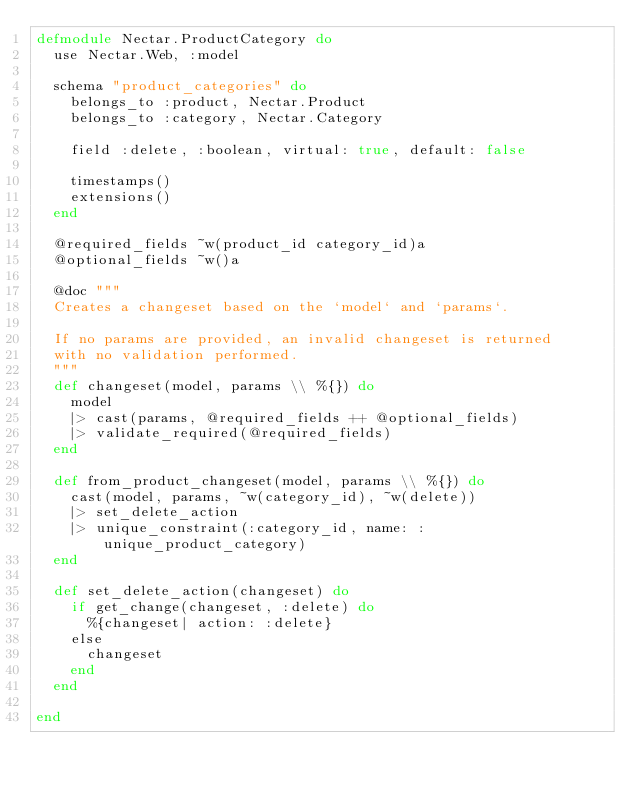Convert code to text. <code><loc_0><loc_0><loc_500><loc_500><_Elixir_>defmodule Nectar.ProductCategory do
  use Nectar.Web, :model

  schema "product_categories" do
    belongs_to :product, Nectar.Product
    belongs_to :category, Nectar.Category

    field :delete, :boolean, virtual: true, default: false

    timestamps()
    extensions()
  end

  @required_fields ~w(product_id category_id)a
  @optional_fields ~w()a

  @doc """
  Creates a changeset based on the `model` and `params`.

  If no params are provided, an invalid changeset is returned
  with no validation performed.
  """
  def changeset(model, params \\ %{}) do
    model
    |> cast(params, @required_fields ++ @optional_fields)
    |> validate_required(@required_fields)
  end

  def from_product_changeset(model, params \\ %{}) do
    cast(model, params, ~w(category_id), ~w(delete))
    |> set_delete_action
    |> unique_constraint(:category_id, name: :unique_product_category)
  end

  def set_delete_action(changeset) do
    if get_change(changeset, :delete) do
      %{changeset| action: :delete}
    else
      changeset
    end
  end

end
</code> 